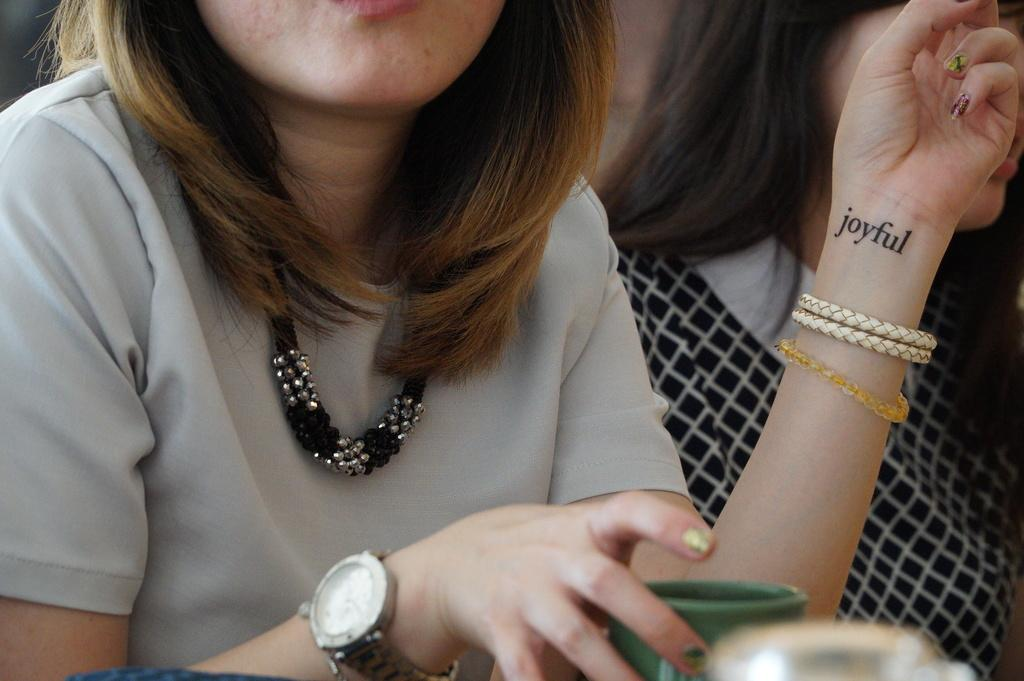<image>
Give a short and clear explanation of the subsequent image. A woman with a tattoo that says Joyful on the inside of her wrist. 